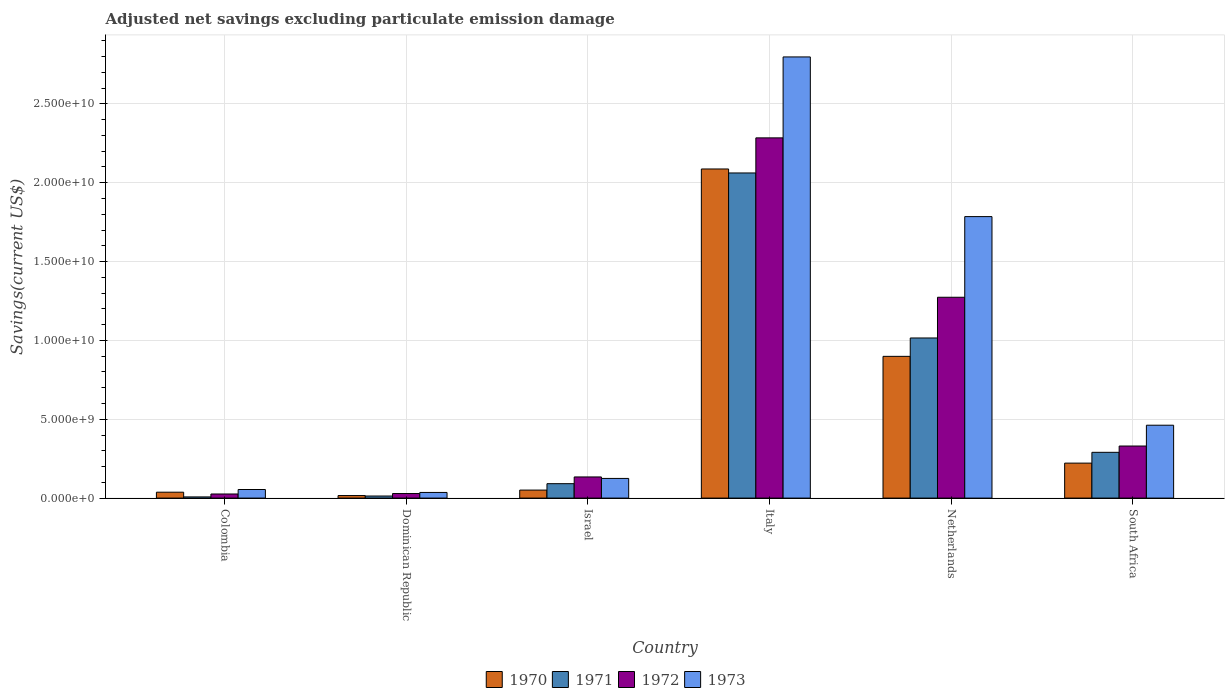Are the number of bars on each tick of the X-axis equal?
Your response must be concise. Yes. How many bars are there on the 5th tick from the right?
Your answer should be very brief. 4. In how many cases, is the number of bars for a given country not equal to the number of legend labels?
Make the answer very short. 0. What is the adjusted net savings in 1970 in South Africa?
Your answer should be compact. 2.22e+09. Across all countries, what is the maximum adjusted net savings in 1972?
Provide a short and direct response. 2.28e+1. Across all countries, what is the minimum adjusted net savings in 1972?
Offer a terse response. 2.60e+08. In which country was the adjusted net savings in 1972 minimum?
Provide a succinct answer. Colombia. What is the total adjusted net savings in 1971 in the graph?
Keep it short and to the point. 3.48e+1. What is the difference between the adjusted net savings in 1973 in Colombia and that in South Africa?
Ensure brevity in your answer.  -4.08e+09. What is the difference between the adjusted net savings in 1970 in Israel and the adjusted net savings in 1973 in Dominican Republic?
Make the answer very short. 1.50e+08. What is the average adjusted net savings in 1973 per country?
Keep it short and to the point. 8.77e+09. What is the difference between the adjusted net savings of/in 1971 and adjusted net savings of/in 1970 in Netherlands?
Make the answer very short. 1.17e+09. What is the ratio of the adjusted net savings in 1972 in Israel to that in Italy?
Ensure brevity in your answer.  0.06. Is the adjusted net savings in 1973 in Colombia less than that in Israel?
Provide a succinct answer. Yes. Is the difference between the adjusted net savings in 1971 in Dominican Republic and South Africa greater than the difference between the adjusted net savings in 1970 in Dominican Republic and South Africa?
Offer a very short reply. No. What is the difference between the highest and the second highest adjusted net savings in 1970?
Your answer should be very brief. 1.19e+1. What is the difference between the highest and the lowest adjusted net savings in 1970?
Provide a short and direct response. 2.07e+1. Is the sum of the adjusted net savings in 1973 in Netherlands and South Africa greater than the maximum adjusted net savings in 1972 across all countries?
Make the answer very short. No. Is it the case that in every country, the sum of the adjusted net savings in 1971 and adjusted net savings in 1970 is greater than the adjusted net savings in 1972?
Your response must be concise. Yes. Are all the bars in the graph horizontal?
Your response must be concise. No. What is the difference between two consecutive major ticks on the Y-axis?
Provide a short and direct response. 5.00e+09. Does the graph contain any zero values?
Give a very brief answer. No. What is the title of the graph?
Your answer should be compact. Adjusted net savings excluding particulate emission damage. Does "2001" appear as one of the legend labels in the graph?
Give a very brief answer. No. What is the label or title of the Y-axis?
Offer a terse response. Savings(current US$). What is the Savings(current US$) of 1970 in Colombia?
Give a very brief answer. 3.74e+08. What is the Savings(current US$) of 1971 in Colombia?
Offer a terse response. 7.46e+07. What is the Savings(current US$) of 1972 in Colombia?
Provide a short and direct response. 2.60e+08. What is the Savings(current US$) of 1973 in Colombia?
Offer a terse response. 5.45e+08. What is the Savings(current US$) in 1970 in Dominican Republic?
Make the answer very short. 1.61e+08. What is the Savings(current US$) in 1971 in Dominican Republic?
Provide a succinct answer. 1.32e+08. What is the Savings(current US$) in 1972 in Dominican Republic?
Your answer should be very brief. 2.89e+08. What is the Savings(current US$) of 1973 in Dominican Republic?
Your response must be concise. 3.58e+08. What is the Savings(current US$) in 1970 in Israel?
Provide a short and direct response. 5.08e+08. What is the Savings(current US$) of 1971 in Israel?
Offer a terse response. 9.14e+08. What is the Savings(current US$) of 1972 in Israel?
Ensure brevity in your answer.  1.34e+09. What is the Savings(current US$) of 1973 in Israel?
Your response must be concise. 1.25e+09. What is the Savings(current US$) in 1970 in Italy?
Give a very brief answer. 2.09e+1. What is the Savings(current US$) in 1971 in Italy?
Give a very brief answer. 2.06e+1. What is the Savings(current US$) of 1972 in Italy?
Your answer should be very brief. 2.28e+1. What is the Savings(current US$) of 1973 in Italy?
Provide a short and direct response. 2.80e+1. What is the Savings(current US$) of 1970 in Netherlands?
Your answer should be compact. 8.99e+09. What is the Savings(current US$) in 1971 in Netherlands?
Provide a short and direct response. 1.02e+1. What is the Savings(current US$) of 1972 in Netherlands?
Your response must be concise. 1.27e+1. What is the Savings(current US$) in 1973 in Netherlands?
Offer a very short reply. 1.79e+1. What is the Savings(current US$) in 1970 in South Africa?
Give a very brief answer. 2.22e+09. What is the Savings(current US$) in 1971 in South Africa?
Ensure brevity in your answer.  2.90e+09. What is the Savings(current US$) of 1972 in South Africa?
Your response must be concise. 3.30e+09. What is the Savings(current US$) in 1973 in South Africa?
Offer a terse response. 4.62e+09. Across all countries, what is the maximum Savings(current US$) in 1970?
Your response must be concise. 2.09e+1. Across all countries, what is the maximum Savings(current US$) of 1971?
Offer a terse response. 2.06e+1. Across all countries, what is the maximum Savings(current US$) of 1972?
Your answer should be compact. 2.28e+1. Across all countries, what is the maximum Savings(current US$) in 1973?
Provide a short and direct response. 2.80e+1. Across all countries, what is the minimum Savings(current US$) in 1970?
Make the answer very short. 1.61e+08. Across all countries, what is the minimum Savings(current US$) in 1971?
Your response must be concise. 7.46e+07. Across all countries, what is the minimum Savings(current US$) in 1972?
Keep it short and to the point. 2.60e+08. Across all countries, what is the minimum Savings(current US$) of 1973?
Your response must be concise. 3.58e+08. What is the total Savings(current US$) of 1970 in the graph?
Give a very brief answer. 3.31e+1. What is the total Savings(current US$) of 1971 in the graph?
Keep it short and to the point. 3.48e+1. What is the total Savings(current US$) in 1972 in the graph?
Offer a terse response. 4.08e+1. What is the total Savings(current US$) of 1973 in the graph?
Ensure brevity in your answer.  5.26e+1. What is the difference between the Savings(current US$) of 1970 in Colombia and that in Dominican Republic?
Your answer should be very brief. 2.13e+08. What is the difference between the Savings(current US$) of 1971 in Colombia and that in Dominican Republic?
Make the answer very short. -5.69e+07. What is the difference between the Savings(current US$) of 1972 in Colombia and that in Dominican Republic?
Your response must be concise. -2.84e+07. What is the difference between the Savings(current US$) of 1973 in Colombia and that in Dominican Republic?
Ensure brevity in your answer.  1.87e+08. What is the difference between the Savings(current US$) in 1970 in Colombia and that in Israel?
Provide a succinct answer. -1.34e+08. What is the difference between the Savings(current US$) in 1971 in Colombia and that in Israel?
Provide a short and direct response. -8.40e+08. What is the difference between the Savings(current US$) in 1972 in Colombia and that in Israel?
Your answer should be very brief. -1.08e+09. What is the difference between the Savings(current US$) of 1973 in Colombia and that in Israel?
Give a very brief answer. -7.02e+08. What is the difference between the Savings(current US$) in 1970 in Colombia and that in Italy?
Keep it short and to the point. -2.05e+1. What is the difference between the Savings(current US$) in 1971 in Colombia and that in Italy?
Keep it short and to the point. -2.05e+1. What is the difference between the Savings(current US$) of 1972 in Colombia and that in Italy?
Provide a short and direct response. -2.26e+1. What is the difference between the Savings(current US$) in 1973 in Colombia and that in Italy?
Your answer should be very brief. -2.74e+1. What is the difference between the Savings(current US$) in 1970 in Colombia and that in Netherlands?
Offer a terse response. -8.61e+09. What is the difference between the Savings(current US$) of 1971 in Colombia and that in Netherlands?
Offer a very short reply. -1.01e+1. What is the difference between the Savings(current US$) of 1972 in Colombia and that in Netherlands?
Your answer should be very brief. -1.25e+1. What is the difference between the Savings(current US$) of 1973 in Colombia and that in Netherlands?
Your response must be concise. -1.73e+1. What is the difference between the Savings(current US$) in 1970 in Colombia and that in South Africa?
Offer a terse response. -1.84e+09. What is the difference between the Savings(current US$) of 1971 in Colombia and that in South Africa?
Keep it short and to the point. -2.83e+09. What is the difference between the Savings(current US$) of 1972 in Colombia and that in South Africa?
Offer a very short reply. -3.04e+09. What is the difference between the Savings(current US$) in 1973 in Colombia and that in South Africa?
Keep it short and to the point. -4.08e+09. What is the difference between the Savings(current US$) of 1970 in Dominican Republic and that in Israel?
Your response must be concise. -3.47e+08. What is the difference between the Savings(current US$) of 1971 in Dominican Republic and that in Israel?
Ensure brevity in your answer.  -7.83e+08. What is the difference between the Savings(current US$) of 1972 in Dominican Republic and that in Israel?
Provide a short and direct response. -1.05e+09. What is the difference between the Savings(current US$) in 1973 in Dominican Republic and that in Israel?
Your answer should be compact. -8.89e+08. What is the difference between the Savings(current US$) in 1970 in Dominican Republic and that in Italy?
Give a very brief answer. -2.07e+1. What is the difference between the Savings(current US$) in 1971 in Dominican Republic and that in Italy?
Your answer should be very brief. -2.05e+1. What is the difference between the Savings(current US$) in 1972 in Dominican Republic and that in Italy?
Make the answer very short. -2.26e+1. What is the difference between the Savings(current US$) in 1973 in Dominican Republic and that in Italy?
Ensure brevity in your answer.  -2.76e+1. What is the difference between the Savings(current US$) of 1970 in Dominican Republic and that in Netherlands?
Provide a succinct answer. -8.83e+09. What is the difference between the Savings(current US$) of 1971 in Dominican Republic and that in Netherlands?
Make the answer very short. -1.00e+1. What is the difference between the Savings(current US$) in 1972 in Dominican Republic and that in Netherlands?
Give a very brief answer. -1.24e+1. What is the difference between the Savings(current US$) in 1973 in Dominican Republic and that in Netherlands?
Ensure brevity in your answer.  -1.75e+1. What is the difference between the Savings(current US$) of 1970 in Dominican Republic and that in South Africa?
Your answer should be compact. -2.06e+09. What is the difference between the Savings(current US$) of 1971 in Dominican Republic and that in South Africa?
Provide a succinct answer. -2.77e+09. What is the difference between the Savings(current US$) of 1972 in Dominican Republic and that in South Africa?
Offer a very short reply. -3.01e+09. What is the difference between the Savings(current US$) of 1973 in Dominican Republic and that in South Africa?
Offer a terse response. -4.26e+09. What is the difference between the Savings(current US$) in 1970 in Israel and that in Italy?
Keep it short and to the point. -2.04e+1. What is the difference between the Savings(current US$) of 1971 in Israel and that in Italy?
Make the answer very short. -1.97e+1. What is the difference between the Savings(current US$) in 1972 in Israel and that in Italy?
Your response must be concise. -2.15e+1. What is the difference between the Savings(current US$) in 1973 in Israel and that in Italy?
Offer a very short reply. -2.67e+1. What is the difference between the Savings(current US$) in 1970 in Israel and that in Netherlands?
Offer a terse response. -8.48e+09. What is the difference between the Savings(current US$) of 1971 in Israel and that in Netherlands?
Your response must be concise. -9.24e+09. What is the difference between the Savings(current US$) in 1972 in Israel and that in Netherlands?
Offer a terse response. -1.14e+1. What is the difference between the Savings(current US$) in 1973 in Israel and that in Netherlands?
Ensure brevity in your answer.  -1.66e+1. What is the difference between the Savings(current US$) of 1970 in Israel and that in South Africa?
Ensure brevity in your answer.  -1.71e+09. What is the difference between the Savings(current US$) in 1971 in Israel and that in South Africa?
Make the answer very short. -1.99e+09. What is the difference between the Savings(current US$) in 1972 in Israel and that in South Africa?
Keep it short and to the point. -1.96e+09. What is the difference between the Savings(current US$) of 1973 in Israel and that in South Africa?
Give a very brief answer. -3.38e+09. What is the difference between the Savings(current US$) in 1970 in Italy and that in Netherlands?
Ensure brevity in your answer.  1.19e+1. What is the difference between the Savings(current US$) in 1971 in Italy and that in Netherlands?
Ensure brevity in your answer.  1.05e+1. What is the difference between the Savings(current US$) in 1972 in Italy and that in Netherlands?
Your answer should be very brief. 1.01e+1. What is the difference between the Savings(current US$) of 1973 in Italy and that in Netherlands?
Ensure brevity in your answer.  1.01e+1. What is the difference between the Savings(current US$) in 1970 in Italy and that in South Africa?
Offer a terse response. 1.87e+1. What is the difference between the Savings(current US$) of 1971 in Italy and that in South Africa?
Offer a very short reply. 1.77e+1. What is the difference between the Savings(current US$) in 1972 in Italy and that in South Africa?
Offer a terse response. 1.95e+1. What is the difference between the Savings(current US$) of 1973 in Italy and that in South Africa?
Keep it short and to the point. 2.34e+1. What is the difference between the Savings(current US$) in 1970 in Netherlands and that in South Africa?
Keep it short and to the point. 6.77e+09. What is the difference between the Savings(current US$) of 1971 in Netherlands and that in South Africa?
Your answer should be compact. 7.25e+09. What is the difference between the Savings(current US$) of 1972 in Netherlands and that in South Africa?
Provide a short and direct response. 9.43e+09. What is the difference between the Savings(current US$) of 1973 in Netherlands and that in South Africa?
Ensure brevity in your answer.  1.32e+1. What is the difference between the Savings(current US$) of 1970 in Colombia and the Savings(current US$) of 1971 in Dominican Republic?
Give a very brief answer. 2.42e+08. What is the difference between the Savings(current US$) in 1970 in Colombia and the Savings(current US$) in 1972 in Dominican Republic?
Your answer should be compact. 8.52e+07. What is the difference between the Savings(current US$) in 1970 in Colombia and the Savings(current US$) in 1973 in Dominican Republic?
Your answer should be very brief. 1.57e+07. What is the difference between the Savings(current US$) in 1971 in Colombia and the Savings(current US$) in 1972 in Dominican Republic?
Your answer should be compact. -2.14e+08. What is the difference between the Savings(current US$) of 1971 in Colombia and the Savings(current US$) of 1973 in Dominican Republic?
Your answer should be compact. -2.84e+08. What is the difference between the Savings(current US$) in 1972 in Colombia and the Savings(current US$) in 1973 in Dominican Republic?
Offer a terse response. -9.79e+07. What is the difference between the Savings(current US$) of 1970 in Colombia and the Savings(current US$) of 1971 in Israel?
Your response must be concise. -5.40e+08. What is the difference between the Savings(current US$) in 1970 in Colombia and the Savings(current US$) in 1972 in Israel?
Offer a terse response. -9.67e+08. What is the difference between the Savings(current US$) of 1970 in Colombia and the Savings(current US$) of 1973 in Israel?
Make the answer very short. -8.73e+08. What is the difference between the Savings(current US$) in 1971 in Colombia and the Savings(current US$) in 1972 in Israel?
Offer a very short reply. -1.27e+09. What is the difference between the Savings(current US$) of 1971 in Colombia and the Savings(current US$) of 1973 in Israel?
Your answer should be very brief. -1.17e+09. What is the difference between the Savings(current US$) in 1972 in Colombia and the Savings(current US$) in 1973 in Israel?
Offer a terse response. -9.87e+08. What is the difference between the Savings(current US$) in 1970 in Colombia and the Savings(current US$) in 1971 in Italy?
Give a very brief answer. -2.02e+1. What is the difference between the Savings(current US$) in 1970 in Colombia and the Savings(current US$) in 1972 in Italy?
Ensure brevity in your answer.  -2.25e+1. What is the difference between the Savings(current US$) in 1970 in Colombia and the Savings(current US$) in 1973 in Italy?
Make the answer very short. -2.76e+1. What is the difference between the Savings(current US$) in 1971 in Colombia and the Savings(current US$) in 1972 in Italy?
Your answer should be compact. -2.28e+1. What is the difference between the Savings(current US$) of 1971 in Colombia and the Savings(current US$) of 1973 in Italy?
Your answer should be compact. -2.79e+1. What is the difference between the Savings(current US$) in 1972 in Colombia and the Savings(current US$) in 1973 in Italy?
Your answer should be compact. -2.77e+1. What is the difference between the Savings(current US$) in 1970 in Colombia and the Savings(current US$) in 1971 in Netherlands?
Offer a very short reply. -9.78e+09. What is the difference between the Savings(current US$) in 1970 in Colombia and the Savings(current US$) in 1972 in Netherlands?
Keep it short and to the point. -1.24e+1. What is the difference between the Savings(current US$) in 1970 in Colombia and the Savings(current US$) in 1973 in Netherlands?
Keep it short and to the point. -1.75e+1. What is the difference between the Savings(current US$) in 1971 in Colombia and the Savings(current US$) in 1972 in Netherlands?
Make the answer very short. -1.27e+1. What is the difference between the Savings(current US$) in 1971 in Colombia and the Savings(current US$) in 1973 in Netherlands?
Offer a very short reply. -1.78e+1. What is the difference between the Savings(current US$) of 1972 in Colombia and the Savings(current US$) of 1973 in Netherlands?
Give a very brief answer. -1.76e+1. What is the difference between the Savings(current US$) of 1970 in Colombia and the Savings(current US$) of 1971 in South Africa?
Offer a terse response. -2.53e+09. What is the difference between the Savings(current US$) in 1970 in Colombia and the Savings(current US$) in 1972 in South Africa?
Ensure brevity in your answer.  -2.93e+09. What is the difference between the Savings(current US$) of 1970 in Colombia and the Savings(current US$) of 1973 in South Africa?
Provide a short and direct response. -4.25e+09. What is the difference between the Savings(current US$) in 1971 in Colombia and the Savings(current US$) in 1972 in South Africa?
Your answer should be very brief. -3.23e+09. What is the difference between the Savings(current US$) of 1971 in Colombia and the Savings(current US$) of 1973 in South Africa?
Your response must be concise. -4.55e+09. What is the difference between the Savings(current US$) of 1972 in Colombia and the Savings(current US$) of 1973 in South Africa?
Your answer should be compact. -4.36e+09. What is the difference between the Savings(current US$) of 1970 in Dominican Republic and the Savings(current US$) of 1971 in Israel?
Your answer should be very brief. -7.53e+08. What is the difference between the Savings(current US$) in 1970 in Dominican Republic and the Savings(current US$) in 1972 in Israel?
Provide a short and direct response. -1.18e+09. What is the difference between the Savings(current US$) in 1970 in Dominican Republic and the Savings(current US$) in 1973 in Israel?
Keep it short and to the point. -1.09e+09. What is the difference between the Savings(current US$) in 1971 in Dominican Republic and the Savings(current US$) in 1972 in Israel?
Give a very brief answer. -1.21e+09. What is the difference between the Savings(current US$) in 1971 in Dominican Republic and the Savings(current US$) in 1973 in Israel?
Give a very brief answer. -1.12e+09. What is the difference between the Savings(current US$) in 1972 in Dominican Republic and the Savings(current US$) in 1973 in Israel?
Keep it short and to the point. -9.58e+08. What is the difference between the Savings(current US$) of 1970 in Dominican Republic and the Savings(current US$) of 1971 in Italy?
Keep it short and to the point. -2.05e+1. What is the difference between the Savings(current US$) of 1970 in Dominican Republic and the Savings(current US$) of 1972 in Italy?
Provide a succinct answer. -2.27e+1. What is the difference between the Savings(current US$) in 1970 in Dominican Republic and the Savings(current US$) in 1973 in Italy?
Make the answer very short. -2.78e+1. What is the difference between the Savings(current US$) in 1971 in Dominican Republic and the Savings(current US$) in 1972 in Italy?
Provide a short and direct response. -2.27e+1. What is the difference between the Savings(current US$) of 1971 in Dominican Republic and the Savings(current US$) of 1973 in Italy?
Ensure brevity in your answer.  -2.78e+1. What is the difference between the Savings(current US$) in 1972 in Dominican Republic and the Savings(current US$) in 1973 in Italy?
Provide a short and direct response. -2.77e+1. What is the difference between the Savings(current US$) in 1970 in Dominican Republic and the Savings(current US$) in 1971 in Netherlands?
Your response must be concise. -9.99e+09. What is the difference between the Savings(current US$) of 1970 in Dominican Republic and the Savings(current US$) of 1972 in Netherlands?
Offer a terse response. -1.26e+1. What is the difference between the Savings(current US$) in 1970 in Dominican Republic and the Savings(current US$) in 1973 in Netherlands?
Provide a short and direct response. -1.77e+1. What is the difference between the Savings(current US$) of 1971 in Dominican Republic and the Savings(current US$) of 1972 in Netherlands?
Ensure brevity in your answer.  -1.26e+1. What is the difference between the Savings(current US$) of 1971 in Dominican Republic and the Savings(current US$) of 1973 in Netherlands?
Your answer should be very brief. -1.77e+1. What is the difference between the Savings(current US$) in 1972 in Dominican Republic and the Savings(current US$) in 1973 in Netherlands?
Make the answer very short. -1.76e+1. What is the difference between the Savings(current US$) in 1970 in Dominican Republic and the Savings(current US$) in 1971 in South Africa?
Offer a very short reply. -2.74e+09. What is the difference between the Savings(current US$) in 1970 in Dominican Republic and the Savings(current US$) in 1972 in South Africa?
Offer a terse response. -3.14e+09. What is the difference between the Savings(current US$) in 1970 in Dominican Republic and the Savings(current US$) in 1973 in South Africa?
Offer a very short reply. -4.46e+09. What is the difference between the Savings(current US$) in 1971 in Dominican Republic and the Savings(current US$) in 1972 in South Africa?
Provide a succinct answer. -3.17e+09. What is the difference between the Savings(current US$) of 1971 in Dominican Republic and the Savings(current US$) of 1973 in South Africa?
Your answer should be very brief. -4.49e+09. What is the difference between the Savings(current US$) in 1972 in Dominican Republic and the Savings(current US$) in 1973 in South Africa?
Your answer should be compact. -4.33e+09. What is the difference between the Savings(current US$) in 1970 in Israel and the Savings(current US$) in 1971 in Italy?
Your response must be concise. -2.01e+1. What is the difference between the Savings(current US$) in 1970 in Israel and the Savings(current US$) in 1972 in Italy?
Provide a succinct answer. -2.23e+1. What is the difference between the Savings(current US$) in 1970 in Israel and the Savings(current US$) in 1973 in Italy?
Provide a short and direct response. -2.75e+1. What is the difference between the Savings(current US$) in 1971 in Israel and the Savings(current US$) in 1972 in Italy?
Offer a terse response. -2.19e+1. What is the difference between the Savings(current US$) in 1971 in Israel and the Savings(current US$) in 1973 in Italy?
Your response must be concise. -2.71e+1. What is the difference between the Savings(current US$) of 1972 in Israel and the Savings(current US$) of 1973 in Italy?
Make the answer very short. -2.66e+1. What is the difference between the Savings(current US$) of 1970 in Israel and the Savings(current US$) of 1971 in Netherlands?
Make the answer very short. -9.65e+09. What is the difference between the Savings(current US$) of 1970 in Israel and the Savings(current US$) of 1972 in Netherlands?
Offer a very short reply. -1.22e+1. What is the difference between the Savings(current US$) of 1970 in Israel and the Savings(current US$) of 1973 in Netherlands?
Your response must be concise. -1.73e+1. What is the difference between the Savings(current US$) in 1971 in Israel and the Savings(current US$) in 1972 in Netherlands?
Ensure brevity in your answer.  -1.18e+1. What is the difference between the Savings(current US$) in 1971 in Israel and the Savings(current US$) in 1973 in Netherlands?
Provide a short and direct response. -1.69e+1. What is the difference between the Savings(current US$) of 1972 in Israel and the Savings(current US$) of 1973 in Netherlands?
Give a very brief answer. -1.65e+1. What is the difference between the Savings(current US$) of 1970 in Israel and the Savings(current US$) of 1971 in South Africa?
Provide a succinct answer. -2.39e+09. What is the difference between the Savings(current US$) of 1970 in Israel and the Savings(current US$) of 1972 in South Africa?
Make the answer very short. -2.79e+09. What is the difference between the Savings(current US$) in 1970 in Israel and the Savings(current US$) in 1973 in South Africa?
Provide a short and direct response. -4.11e+09. What is the difference between the Savings(current US$) of 1971 in Israel and the Savings(current US$) of 1972 in South Africa?
Keep it short and to the point. -2.39e+09. What is the difference between the Savings(current US$) in 1971 in Israel and the Savings(current US$) in 1973 in South Africa?
Provide a succinct answer. -3.71e+09. What is the difference between the Savings(current US$) in 1972 in Israel and the Savings(current US$) in 1973 in South Africa?
Your answer should be very brief. -3.28e+09. What is the difference between the Savings(current US$) of 1970 in Italy and the Savings(current US$) of 1971 in Netherlands?
Offer a very short reply. 1.07e+1. What is the difference between the Savings(current US$) in 1970 in Italy and the Savings(current US$) in 1972 in Netherlands?
Offer a very short reply. 8.14e+09. What is the difference between the Savings(current US$) of 1970 in Italy and the Savings(current US$) of 1973 in Netherlands?
Ensure brevity in your answer.  3.02e+09. What is the difference between the Savings(current US$) of 1971 in Italy and the Savings(current US$) of 1972 in Netherlands?
Offer a very short reply. 7.88e+09. What is the difference between the Savings(current US$) of 1971 in Italy and the Savings(current US$) of 1973 in Netherlands?
Your response must be concise. 2.77e+09. What is the difference between the Savings(current US$) of 1972 in Italy and the Savings(current US$) of 1973 in Netherlands?
Your answer should be very brief. 4.99e+09. What is the difference between the Savings(current US$) in 1970 in Italy and the Savings(current US$) in 1971 in South Africa?
Provide a short and direct response. 1.80e+1. What is the difference between the Savings(current US$) of 1970 in Italy and the Savings(current US$) of 1972 in South Africa?
Provide a succinct answer. 1.76e+1. What is the difference between the Savings(current US$) of 1970 in Italy and the Savings(current US$) of 1973 in South Africa?
Make the answer very short. 1.62e+1. What is the difference between the Savings(current US$) of 1971 in Italy and the Savings(current US$) of 1972 in South Africa?
Offer a very short reply. 1.73e+1. What is the difference between the Savings(current US$) of 1971 in Italy and the Savings(current US$) of 1973 in South Africa?
Give a very brief answer. 1.60e+1. What is the difference between the Savings(current US$) of 1972 in Italy and the Savings(current US$) of 1973 in South Africa?
Provide a short and direct response. 1.82e+1. What is the difference between the Savings(current US$) of 1970 in Netherlands and the Savings(current US$) of 1971 in South Africa?
Your response must be concise. 6.09e+09. What is the difference between the Savings(current US$) in 1970 in Netherlands and the Savings(current US$) in 1972 in South Africa?
Keep it short and to the point. 5.69e+09. What is the difference between the Savings(current US$) in 1970 in Netherlands and the Savings(current US$) in 1973 in South Africa?
Keep it short and to the point. 4.37e+09. What is the difference between the Savings(current US$) of 1971 in Netherlands and the Savings(current US$) of 1972 in South Africa?
Give a very brief answer. 6.85e+09. What is the difference between the Savings(current US$) of 1971 in Netherlands and the Savings(current US$) of 1973 in South Africa?
Ensure brevity in your answer.  5.53e+09. What is the difference between the Savings(current US$) of 1972 in Netherlands and the Savings(current US$) of 1973 in South Africa?
Offer a terse response. 8.11e+09. What is the average Savings(current US$) of 1970 per country?
Your answer should be very brief. 5.52e+09. What is the average Savings(current US$) in 1971 per country?
Give a very brief answer. 5.80e+09. What is the average Savings(current US$) of 1972 per country?
Your response must be concise. 6.80e+09. What is the average Savings(current US$) in 1973 per country?
Offer a terse response. 8.77e+09. What is the difference between the Savings(current US$) of 1970 and Savings(current US$) of 1971 in Colombia?
Your answer should be compact. 2.99e+08. What is the difference between the Savings(current US$) in 1970 and Savings(current US$) in 1972 in Colombia?
Offer a terse response. 1.14e+08. What is the difference between the Savings(current US$) of 1970 and Savings(current US$) of 1973 in Colombia?
Provide a succinct answer. -1.71e+08. What is the difference between the Savings(current US$) of 1971 and Savings(current US$) of 1972 in Colombia?
Offer a terse response. -1.86e+08. What is the difference between the Savings(current US$) in 1971 and Savings(current US$) in 1973 in Colombia?
Make the answer very short. -4.70e+08. What is the difference between the Savings(current US$) in 1972 and Savings(current US$) in 1973 in Colombia?
Keep it short and to the point. -2.85e+08. What is the difference between the Savings(current US$) in 1970 and Savings(current US$) in 1971 in Dominican Republic?
Offer a terse response. 2.96e+07. What is the difference between the Savings(current US$) in 1970 and Savings(current US$) in 1972 in Dominican Republic?
Offer a very short reply. -1.28e+08. What is the difference between the Savings(current US$) of 1970 and Savings(current US$) of 1973 in Dominican Republic?
Provide a short and direct response. -1.97e+08. What is the difference between the Savings(current US$) in 1971 and Savings(current US$) in 1972 in Dominican Republic?
Make the answer very short. -1.57e+08. What is the difference between the Savings(current US$) of 1971 and Savings(current US$) of 1973 in Dominican Republic?
Your answer should be very brief. -2.27e+08. What is the difference between the Savings(current US$) in 1972 and Savings(current US$) in 1973 in Dominican Republic?
Offer a terse response. -6.95e+07. What is the difference between the Savings(current US$) in 1970 and Savings(current US$) in 1971 in Israel?
Give a very brief answer. -4.06e+08. What is the difference between the Savings(current US$) of 1970 and Savings(current US$) of 1972 in Israel?
Offer a very short reply. -8.33e+08. What is the difference between the Savings(current US$) in 1970 and Savings(current US$) in 1973 in Israel?
Provide a short and direct response. -7.39e+08. What is the difference between the Savings(current US$) of 1971 and Savings(current US$) of 1972 in Israel?
Make the answer very short. -4.27e+08. What is the difference between the Savings(current US$) of 1971 and Savings(current US$) of 1973 in Israel?
Provide a succinct answer. -3.33e+08. What is the difference between the Savings(current US$) in 1972 and Savings(current US$) in 1973 in Israel?
Provide a succinct answer. 9.40e+07. What is the difference between the Savings(current US$) of 1970 and Savings(current US$) of 1971 in Italy?
Make the answer very short. 2.53e+08. What is the difference between the Savings(current US$) in 1970 and Savings(current US$) in 1972 in Italy?
Provide a succinct answer. -1.97e+09. What is the difference between the Savings(current US$) of 1970 and Savings(current US$) of 1973 in Italy?
Provide a succinct answer. -7.11e+09. What is the difference between the Savings(current US$) in 1971 and Savings(current US$) in 1972 in Italy?
Offer a terse response. -2.23e+09. What is the difference between the Savings(current US$) in 1971 and Savings(current US$) in 1973 in Italy?
Give a very brief answer. -7.36e+09. What is the difference between the Savings(current US$) of 1972 and Savings(current US$) of 1973 in Italy?
Give a very brief answer. -5.13e+09. What is the difference between the Savings(current US$) of 1970 and Savings(current US$) of 1971 in Netherlands?
Your response must be concise. -1.17e+09. What is the difference between the Savings(current US$) in 1970 and Savings(current US$) in 1972 in Netherlands?
Your response must be concise. -3.75e+09. What is the difference between the Savings(current US$) of 1970 and Savings(current US$) of 1973 in Netherlands?
Provide a short and direct response. -8.86e+09. What is the difference between the Savings(current US$) in 1971 and Savings(current US$) in 1972 in Netherlands?
Your answer should be very brief. -2.58e+09. What is the difference between the Savings(current US$) in 1971 and Savings(current US$) in 1973 in Netherlands?
Ensure brevity in your answer.  -7.70e+09. What is the difference between the Savings(current US$) of 1972 and Savings(current US$) of 1973 in Netherlands?
Provide a short and direct response. -5.11e+09. What is the difference between the Savings(current US$) in 1970 and Savings(current US$) in 1971 in South Africa?
Your response must be concise. -6.85e+08. What is the difference between the Savings(current US$) in 1970 and Savings(current US$) in 1972 in South Africa?
Your answer should be compact. -1.08e+09. What is the difference between the Savings(current US$) of 1970 and Savings(current US$) of 1973 in South Africa?
Your answer should be compact. -2.40e+09. What is the difference between the Savings(current US$) in 1971 and Savings(current US$) in 1972 in South Africa?
Make the answer very short. -4.00e+08. What is the difference between the Savings(current US$) in 1971 and Savings(current US$) in 1973 in South Africa?
Offer a terse response. -1.72e+09. What is the difference between the Savings(current US$) in 1972 and Savings(current US$) in 1973 in South Africa?
Your answer should be compact. -1.32e+09. What is the ratio of the Savings(current US$) of 1970 in Colombia to that in Dominican Republic?
Make the answer very short. 2.32. What is the ratio of the Savings(current US$) of 1971 in Colombia to that in Dominican Republic?
Keep it short and to the point. 0.57. What is the ratio of the Savings(current US$) in 1972 in Colombia to that in Dominican Republic?
Give a very brief answer. 0.9. What is the ratio of the Savings(current US$) of 1973 in Colombia to that in Dominican Republic?
Give a very brief answer. 1.52. What is the ratio of the Savings(current US$) in 1970 in Colombia to that in Israel?
Offer a terse response. 0.74. What is the ratio of the Savings(current US$) in 1971 in Colombia to that in Israel?
Offer a terse response. 0.08. What is the ratio of the Savings(current US$) in 1972 in Colombia to that in Israel?
Your answer should be very brief. 0.19. What is the ratio of the Savings(current US$) of 1973 in Colombia to that in Israel?
Provide a short and direct response. 0.44. What is the ratio of the Savings(current US$) in 1970 in Colombia to that in Italy?
Make the answer very short. 0.02. What is the ratio of the Savings(current US$) in 1971 in Colombia to that in Italy?
Your answer should be very brief. 0. What is the ratio of the Savings(current US$) of 1972 in Colombia to that in Italy?
Your answer should be compact. 0.01. What is the ratio of the Savings(current US$) of 1973 in Colombia to that in Italy?
Offer a very short reply. 0.02. What is the ratio of the Savings(current US$) of 1970 in Colombia to that in Netherlands?
Give a very brief answer. 0.04. What is the ratio of the Savings(current US$) of 1971 in Colombia to that in Netherlands?
Offer a terse response. 0.01. What is the ratio of the Savings(current US$) of 1972 in Colombia to that in Netherlands?
Your answer should be very brief. 0.02. What is the ratio of the Savings(current US$) in 1973 in Colombia to that in Netherlands?
Your response must be concise. 0.03. What is the ratio of the Savings(current US$) in 1970 in Colombia to that in South Africa?
Ensure brevity in your answer.  0.17. What is the ratio of the Savings(current US$) in 1971 in Colombia to that in South Africa?
Your answer should be very brief. 0.03. What is the ratio of the Savings(current US$) in 1972 in Colombia to that in South Africa?
Offer a very short reply. 0.08. What is the ratio of the Savings(current US$) of 1973 in Colombia to that in South Africa?
Offer a terse response. 0.12. What is the ratio of the Savings(current US$) of 1970 in Dominican Republic to that in Israel?
Ensure brevity in your answer.  0.32. What is the ratio of the Savings(current US$) in 1971 in Dominican Republic to that in Israel?
Your answer should be very brief. 0.14. What is the ratio of the Savings(current US$) of 1972 in Dominican Republic to that in Israel?
Offer a terse response. 0.22. What is the ratio of the Savings(current US$) in 1973 in Dominican Republic to that in Israel?
Give a very brief answer. 0.29. What is the ratio of the Savings(current US$) in 1970 in Dominican Republic to that in Italy?
Offer a terse response. 0.01. What is the ratio of the Savings(current US$) in 1971 in Dominican Republic to that in Italy?
Ensure brevity in your answer.  0.01. What is the ratio of the Savings(current US$) of 1972 in Dominican Republic to that in Italy?
Offer a terse response. 0.01. What is the ratio of the Savings(current US$) in 1973 in Dominican Republic to that in Italy?
Offer a very short reply. 0.01. What is the ratio of the Savings(current US$) in 1970 in Dominican Republic to that in Netherlands?
Make the answer very short. 0.02. What is the ratio of the Savings(current US$) in 1971 in Dominican Republic to that in Netherlands?
Keep it short and to the point. 0.01. What is the ratio of the Savings(current US$) of 1972 in Dominican Republic to that in Netherlands?
Provide a short and direct response. 0.02. What is the ratio of the Savings(current US$) in 1973 in Dominican Republic to that in Netherlands?
Provide a short and direct response. 0.02. What is the ratio of the Savings(current US$) in 1970 in Dominican Republic to that in South Africa?
Give a very brief answer. 0.07. What is the ratio of the Savings(current US$) of 1971 in Dominican Republic to that in South Africa?
Ensure brevity in your answer.  0.05. What is the ratio of the Savings(current US$) of 1972 in Dominican Republic to that in South Africa?
Offer a terse response. 0.09. What is the ratio of the Savings(current US$) of 1973 in Dominican Republic to that in South Africa?
Make the answer very short. 0.08. What is the ratio of the Savings(current US$) in 1970 in Israel to that in Italy?
Your answer should be very brief. 0.02. What is the ratio of the Savings(current US$) in 1971 in Israel to that in Italy?
Your answer should be compact. 0.04. What is the ratio of the Savings(current US$) of 1972 in Israel to that in Italy?
Make the answer very short. 0.06. What is the ratio of the Savings(current US$) of 1973 in Israel to that in Italy?
Offer a very short reply. 0.04. What is the ratio of the Savings(current US$) of 1970 in Israel to that in Netherlands?
Ensure brevity in your answer.  0.06. What is the ratio of the Savings(current US$) of 1971 in Israel to that in Netherlands?
Provide a short and direct response. 0.09. What is the ratio of the Savings(current US$) in 1972 in Israel to that in Netherlands?
Your response must be concise. 0.11. What is the ratio of the Savings(current US$) of 1973 in Israel to that in Netherlands?
Ensure brevity in your answer.  0.07. What is the ratio of the Savings(current US$) of 1970 in Israel to that in South Africa?
Keep it short and to the point. 0.23. What is the ratio of the Savings(current US$) in 1971 in Israel to that in South Africa?
Ensure brevity in your answer.  0.32. What is the ratio of the Savings(current US$) in 1972 in Israel to that in South Africa?
Offer a very short reply. 0.41. What is the ratio of the Savings(current US$) of 1973 in Israel to that in South Africa?
Provide a succinct answer. 0.27. What is the ratio of the Savings(current US$) of 1970 in Italy to that in Netherlands?
Your answer should be very brief. 2.32. What is the ratio of the Savings(current US$) of 1971 in Italy to that in Netherlands?
Provide a short and direct response. 2.03. What is the ratio of the Savings(current US$) of 1972 in Italy to that in Netherlands?
Your response must be concise. 1.79. What is the ratio of the Savings(current US$) of 1973 in Italy to that in Netherlands?
Provide a succinct answer. 1.57. What is the ratio of the Savings(current US$) of 1970 in Italy to that in South Africa?
Your answer should be very brief. 9.41. What is the ratio of the Savings(current US$) of 1971 in Italy to that in South Africa?
Your answer should be compact. 7.1. What is the ratio of the Savings(current US$) in 1972 in Italy to that in South Africa?
Offer a very short reply. 6.92. What is the ratio of the Savings(current US$) in 1973 in Italy to that in South Africa?
Your response must be concise. 6.05. What is the ratio of the Savings(current US$) of 1970 in Netherlands to that in South Africa?
Your answer should be compact. 4.05. What is the ratio of the Savings(current US$) in 1971 in Netherlands to that in South Africa?
Provide a succinct answer. 3.5. What is the ratio of the Savings(current US$) in 1972 in Netherlands to that in South Africa?
Provide a succinct answer. 3.86. What is the ratio of the Savings(current US$) in 1973 in Netherlands to that in South Africa?
Provide a succinct answer. 3.86. What is the difference between the highest and the second highest Savings(current US$) of 1970?
Your answer should be compact. 1.19e+1. What is the difference between the highest and the second highest Savings(current US$) of 1971?
Provide a short and direct response. 1.05e+1. What is the difference between the highest and the second highest Savings(current US$) of 1972?
Offer a very short reply. 1.01e+1. What is the difference between the highest and the second highest Savings(current US$) in 1973?
Give a very brief answer. 1.01e+1. What is the difference between the highest and the lowest Savings(current US$) of 1970?
Provide a short and direct response. 2.07e+1. What is the difference between the highest and the lowest Savings(current US$) of 1971?
Make the answer very short. 2.05e+1. What is the difference between the highest and the lowest Savings(current US$) of 1972?
Offer a terse response. 2.26e+1. What is the difference between the highest and the lowest Savings(current US$) in 1973?
Your response must be concise. 2.76e+1. 